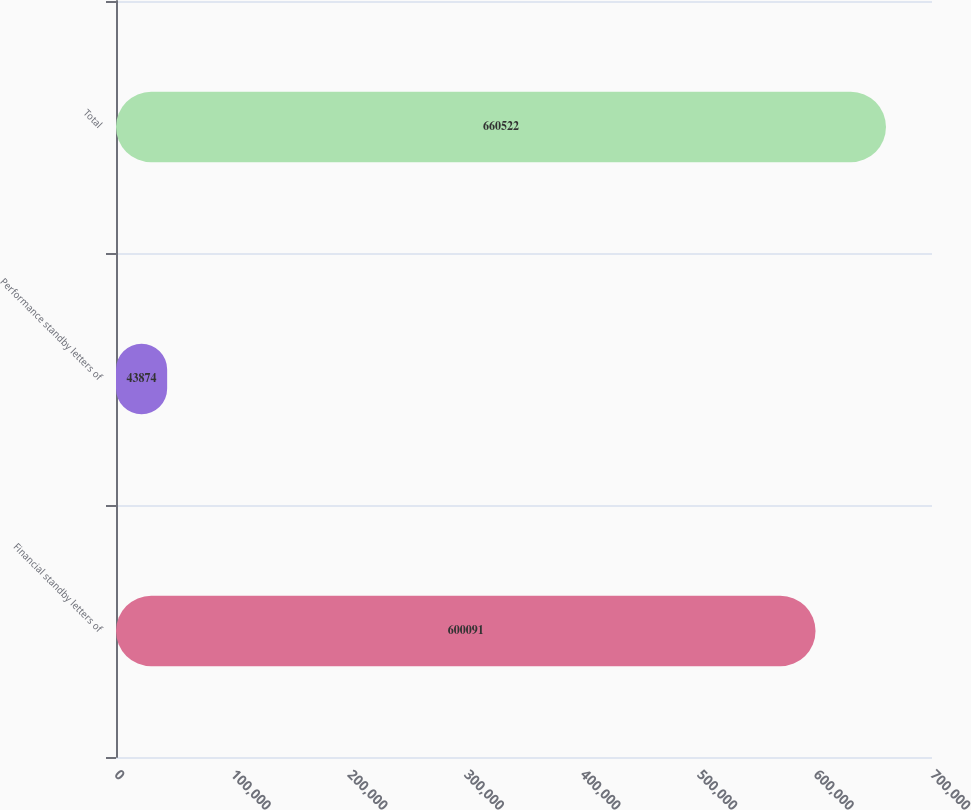Convert chart. <chart><loc_0><loc_0><loc_500><loc_500><bar_chart><fcel>Financial standby letters of<fcel>Performance standby letters of<fcel>Total<nl><fcel>600091<fcel>43874<fcel>660522<nl></chart> 